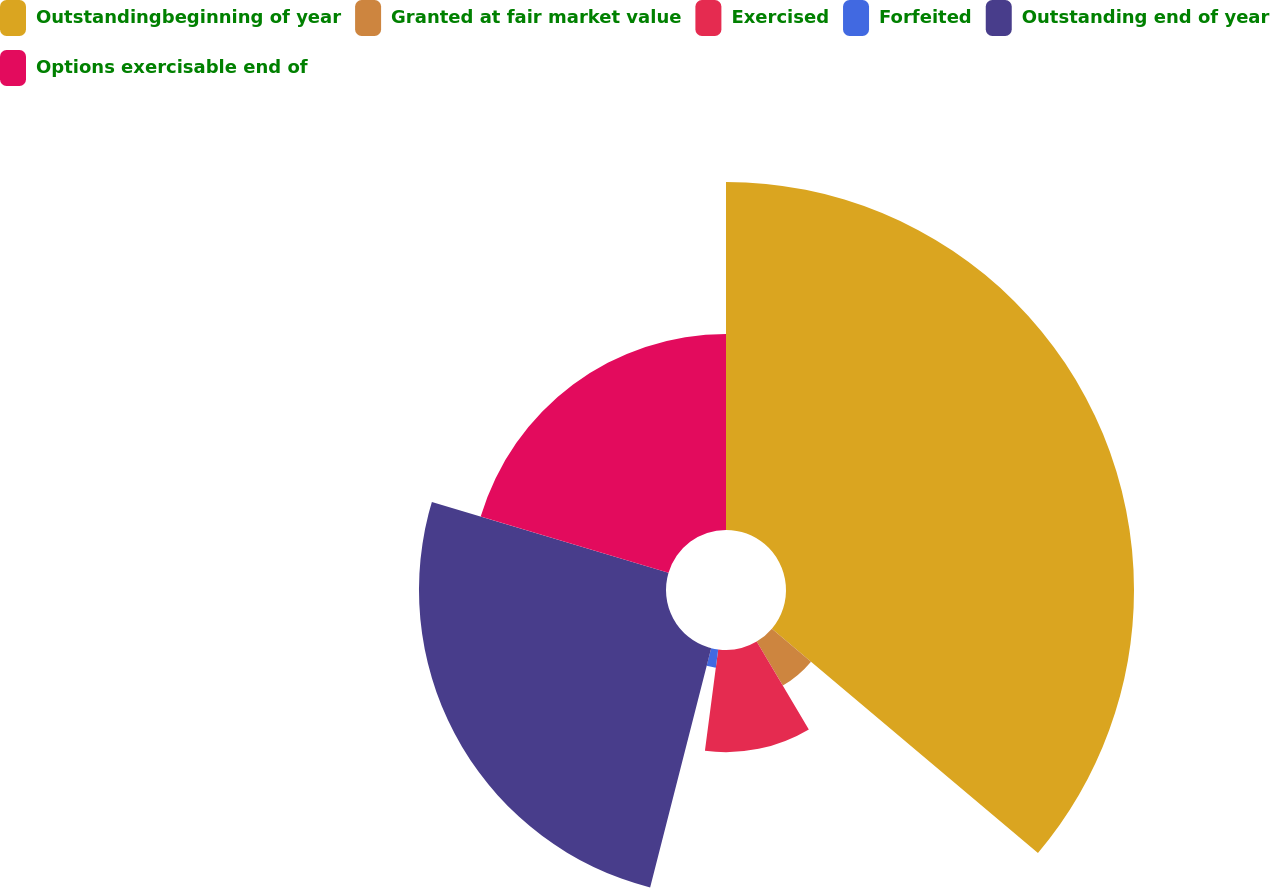Convert chart. <chart><loc_0><loc_0><loc_500><loc_500><pie_chart><fcel>Outstandingbeginning of year<fcel>Granted at fair market value<fcel>Exercised<fcel>Forfeited<fcel>Outstanding end of year<fcel>Options exercisable end of<nl><fcel>36.15%<fcel>5.32%<fcel>10.61%<fcel>1.9%<fcel>25.66%<fcel>20.37%<nl></chart> 